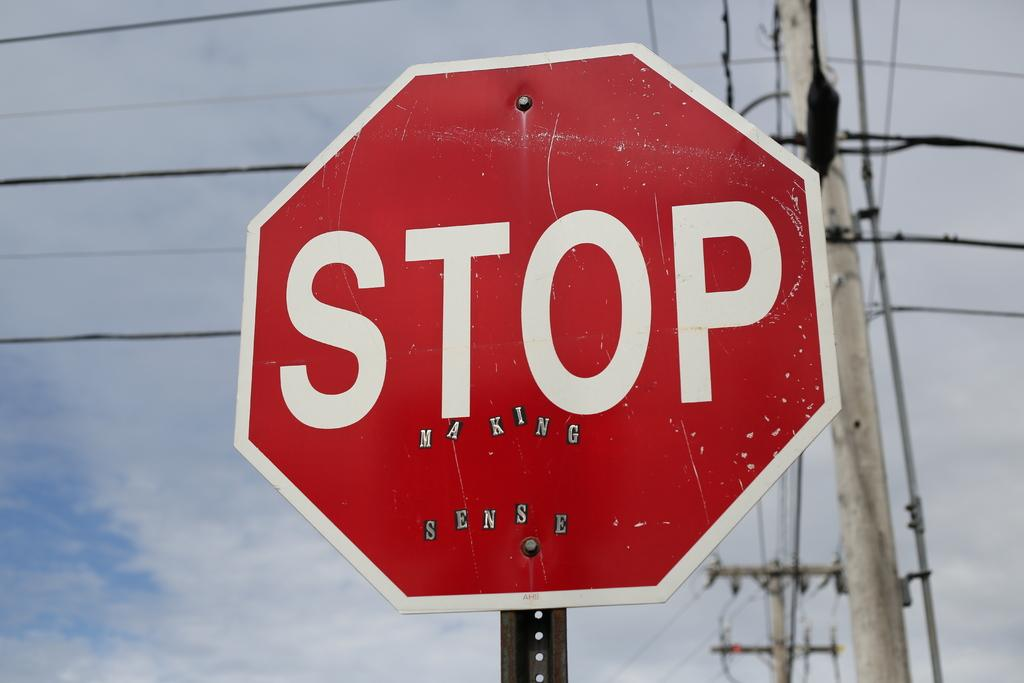<image>
Give a short and clear explanation of the subsequent image. Someone has graffitied this sign with the stickers making sense. 